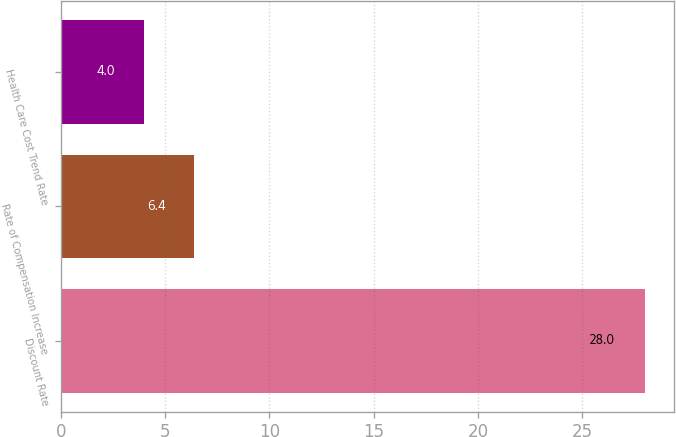Convert chart. <chart><loc_0><loc_0><loc_500><loc_500><bar_chart><fcel>Discount Rate<fcel>Rate of Compensation Increase<fcel>Health Care Cost Trend Rate<nl><fcel>28<fcel>6.4<fcel>4<nl></chart> 